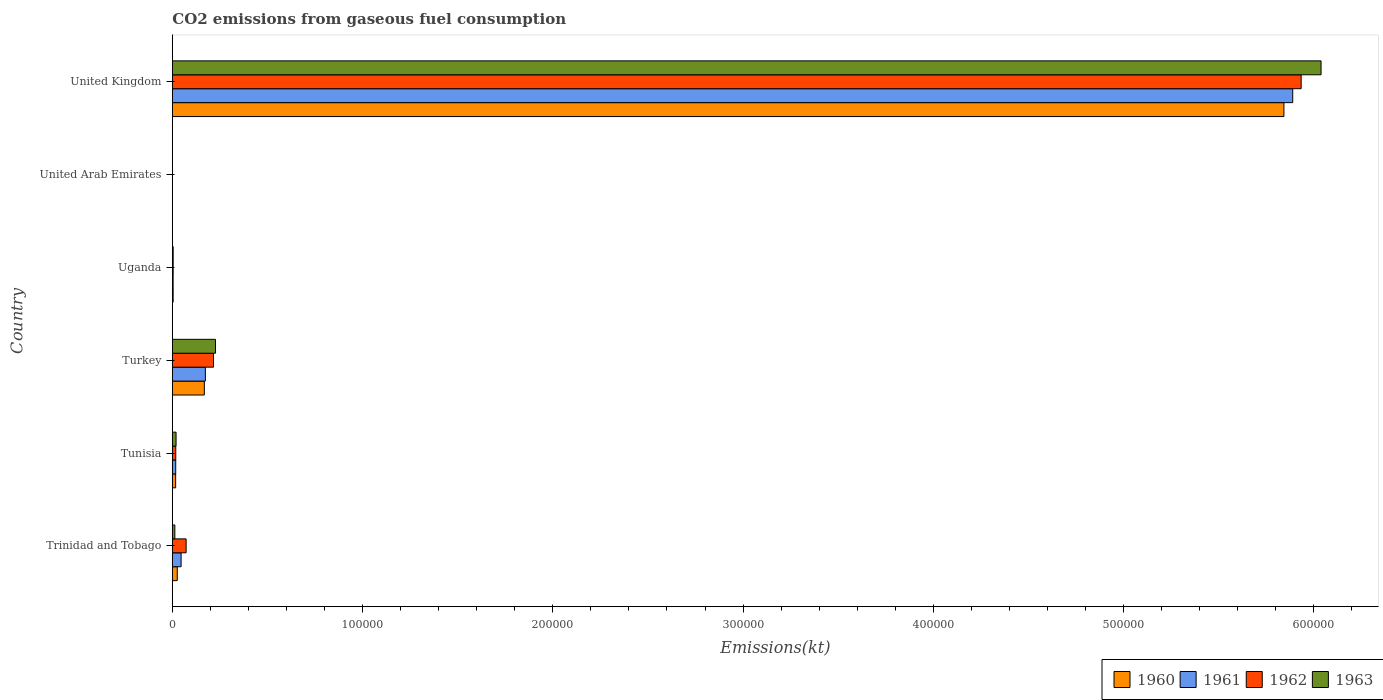Are the number of bars per tick equal to the number of legend labels?
Your answer should be compact. Yes. In how many cases, is the number of bars for a given country not equal to the number of legend labels?
Offer a very short reply. 0. What is the amount of CO2 emitted in 1963 in Tunisia?
Offer a very short reply. 1947.18. Across all countries, what is the maximum amount of CO2 emitted in 1960?
Your response must be concise. 5.84e+05. Across all countries, what is the minimum amount of CO2 emitted in 1961?
Make the answer very short. 11. In which country was the amount of CO2 emitted in 1962 minimum?
Keep it short and to the point. United Arab Emirates. What is the total amount of CO2 emitted in 1963 in the graph?
Give a very brief answer. 6.30e+05. What is the difference between the amount of CO2 emitted in 1960 in Tunisia and that in United Kingdom?
Your answer should be compact. -5.83e+05. What is the difference between the amount of CO2 emitted in 1961 in Trinidad and Tobago and the amount of CO2 emitted in 1960 in United Arab Emirates?
Your answer should be compact. 4591.08. What is the average amount of CO2 emitted in 1961 per country?
Offer a terse response. 1.02e+05. What is the difference between the amount of CO2 emitted in 1962 and amount of CO2 emitted in 1960 in Uganda?
Offer a terse response. 7.33. In how many countries, is the amount of CO2 emitted in 1963 greater than 160000 kt?
Your answer should be very brief. 1. What is the ratio of the amount of CO2 emitted in 1963 in Tunisia to that in Turkey?
Your answer should be very brief. 0.09. What is the difference between the highest and the second highest amount of CO2 emitted in 1960?
Your answer should be very brief. 5.67e+05. What is the difference between the highest and the lowest amount of CO2 emitted in 1962?
Keep it short and to the point. 5.93e+05. In how many countries, is the amount of CO2 emitted in 1960 greater than the average amount of CO2 emitted in 1960 taken over all countries?
Your answer should be very brief. 1. Is the sum of the amount of CO2 emitted in 1963 in Trinidad and Tobago and Tunisia greater than the maximum amount of CO2 emitted in 1960 across all countries?
Offer a very short reply. No. What does the 1st bar from the bottom in Trinidad and Tobago represents?
Offer a very short reply. 1960. Is it the case that in every country, the sum of the amount of CO2 emitted in 1961 and amount of CO2 emitted in 1960 is greater than the amount of CO2 emitted in 1963?
Keep it short and to the point. No. How many countries are there in the graph?
Make the answer very short. 6. What is the difference between two consecutive major ticks on the X-axis?
Your answer should be compact. 1.00e+05. Are the values on the major ticks of X-axis written in scientific E-notation?
Provide a short and direct response. No. Does the graph contain any zero values?
Offer a terse response. No. Where does the legend appear in the graph?
Your answer should be compact. Bottom right. What is the title of the graph?
Give a very brief answer. CO2 emissions from gaseous fuel consumption. What is the label or title of the X-axis?
Your answer should be very brief. Emissions(kt). What is the Emissions(kt) in 1960 in Trinidad and Tobago?
Your response must be concise. 2581.57. What is the Emissions(kt) in 1961 in Trinidad and Tobago?
Make the answer very short. 4602.09. What is the Emissions(kt) in 1962 in Trinidad and Tobago?
Your response must be concise. 7238.66. What is the Emissions(kt) of 1963 in Trinidad and Tobago?
Your answer should be very brief. 1309.12. What is the Emissions(kt) in 1960 in Tunisia?
Keep it short and to the point. 1727.16. What is the Emissions(kt) in 1961 in Tunisia?
Offer a very short reply. 1767.49. What is the Emissions(kt) of 1962 in Tunisia?
Your answer should be very brief. 1796.83. What is the Emissions(kt) of 1963 in Tunisia?
Provide a succinct answer. 1947.18. What is the Emissions(kt) in 1960 in Turkey?
Ensure brevity in your answer.  1.68e+04. What is the Emissions(kt) of 1961 in Turkey?
Ensure brevity in your answer.  1.74e+04. What is the Emissions(kt) in 1962 in Turkey?
Keep it short and to the point. 2.16e+04. What is the Emissions(kt) in 1963 in Turkey?
Provide a short and direct response. 2.27e+04. What is the Emissions(kt) in 1960 in Uganda?
Make the answer very short. 421.7. What is the Emissions(kt) in 1961 in Uganda?
Make the answer very short. 407.04. What is the Emissions(kt) in 1962 in Uganda?
Give a very brief answer. 429.04. What is the Emissions(kt) in 1963 in Uganda?
Give a very brief answer. 432.71. What is the Emissions(kt) in 1960 in United Arab Emirates?
Keep it short and to the point. 11. What is the Emissions(kt) of 1961 in United Arab Emirates?
Keep it short and to the point. 11. What is the Emissions(kt) in 1962 in United Arab Emirates?
Ensure brevity in your answer.  18.34. What is the Emissions(kt) of 1963 in United Arab Emirates?
Your response must be concise. 22. What is the Emissions(kt) of 1960 in United Kingdom?
Offer a very short reply. 5.84e+05. What is the Emissions(kt) of 1961 in United Kingdom?
Give a very brief answer. 5.89e+05. What is the Emissions(kt) of 1962 in United Kingdom?
Give a very brief answer. 5.93e+05. What is the Emissions(kt) of 1963 in United Kingdom?
Give a very brief answer. 6.04e+05. Across all countries, what is the maximum Emissions(kt) of 1960?
Offer a terse response. 5.84e+05. Across all countries, what is the maximum Emissions(kt) of 1961?
Provide a succinct answer. 5.89e+05. Across all countries, what is the maximum Emissions(kt) of 1962?
Give a very brief answer. 5.93e+05. Across all countries, what is the maximum Emissions(kt) of 1963?
Offer a very short reply. 6.04e+05. Across all countries, what is the minimum Emissions(kt) of 1960?
Your response must be concise. 11. Across all countries, what is the minimum Emissions(kt) in 1961?
Offer a terse response. 11. Across all countries, what is the minimum Emissions(kt) in 1962?
Keep it short and to the point. 18.34. Across all countries, what is the minimum Emissions(kt) in 1963?
Provide a short and direct response. 22. What is the total Emissions(kt) in 1960 in the graph?
Your answer should be very brief. 6.06e+05. What is the total Emissions(kt) of 1961 in the graph?
Keep it short and to the point. 6.13e+05. What is the total Emissions(kt) of 1962 in the graph?
Your response must be concise. 6.24e+05. What is the total Emissions(kt) in 1963 in the graph?
Make the answer very short. 6.30e+05. What is the difference between the Emissions(kt) in 1960 in Trinidad and Tobago and that in Tunisia?
Your answer should be compact. 854.41. What is the difference between the Emissions(kt) in 1961 in Trinidad and Tobago and that in Tunisia?
Offer a very short reply. 2834.59. What is the difference between the Emissions(kt) of 1962 in Trinidad and Tobago and that in Tunisia?
Give a very brief answer. 5441.83. What is the difference between the Emissions(kt) of 1963 in Trinidad and Tobago and that in Tunisia?
Your answer should be very brief. -638.06. What is the difference between the Emissions(kt) in 1960 in Trinidad and Tobago and that in Turkey?
Provide a succinct answer. -1.42e+04. What is the difference between the Emissions(kt) in 1961 in Trinidad and Tobago and that in Turkey?
Ensure brevity in your answer.  -1.28e+04. What is the difference between the Emissions(kt) of 1962 in Trinidad and Tobago and that in Turkey?
Your answer should be compact. -1.44e+04. What is the difference between the Emissions(kt) in 1963 in Trinidad and Tobago and that in Turkey?
Keep it short and to the point. -2.14e+04. What is the difference between the Emissions(kt) of 1960 in Trinidad and Tobago and that in Uganda?
Ensure brevity in your answer.  2159.86. What is the difference between the Emissions(kt) in 1961 in Trinidad and Tobago and that in Uganda?
Your answer should be very brief. 4195.05. What is the difference between the Emissions(kt) in 1962 in Trinidad and Tobago and that in Uganda?
Your answer should be very brief. 6809.62. What is the difference between the Emissions(kt) in 1963 in Trinidad and Tobago and that in Uganda?
Your answer should be compact. 876.41. What is the difference between the Emissions(kt) of 1960 in Trinidad and Tobago and that in United Arab Emirates?
Ensure brevity in your answer.  2570.57. What is the difference between the Emissions(kt) of 1961 in Trinidad and Tobago and that in United Arab Emirates?
Provide a succinct answer. 4591.08. What is the difference between the Emissions(kt) of 1962 in Trinidad and Tobago and that in United Arab Emirates?
Your answer should be compact. 7220.32. What is the difference between the Emissions(kt) of 1963 in Trinidad and Tobago and that in United Arab Emirates?
Offer a very short reply. 1287.12. What is the difference between the Emissions(kt) in 1960 in Trinidad and Tobago and that in United Kingdom?
Offer a very short reply. -5.82e+05. What is the difference between the Emissions(kt) in 1961 in Trinidad and Tobago and that in United Kingdom?
Your answer should be compact. -5.84e+05. What is the difference between the Emissions(kt) in 1962 in Trinidad and Tobago and that in United Kingdom?
Keep it short and to the point. -5.86e+05. What is the difference between the Emissions(kt) in 1963 in Trinidad and Tobago and that in United Kingdom?
Offer a very short reply. -6.03e+05. What is the difference between the Emissions(kt) of 1960 in Tunisia and that in Turkey?
Make the answer very short. -1.51e+04. What is the difference between the Emissions(kt) in 1961 in Tunisia and that in Turkey?
Your response must be concise. -1.56e+04. What is the difference between the Emissions(kt) in 1962 in Tunisia and that in Turkey?
Offer a terse response. -1.98e+04. What is the difference between the Emissions(kt) in 1963 in Tunisia and that in Turkey?
Offer a very short reply. -2.07e+04. What is the difference between the Emissions(kt) in 1960 in Tunisia and that in Uganda?
Your answer should be compact. 1305.45. What is the difference between the Emissions(kt) of 1961 in Tunisia and that in Uganda?
Provide a short and direct response. 1360.46. What is the difference between the Emissions(kt) of 1962 in Tunisia and that in Uganda?
Make the answer very short. 1367.79. What is the difference between the Emissions(kt) in 1963 in Tunisia and that in Uganda?
Provide a short and direct response. 1514.47. What is the difference between the Emissions(kt) in 1960 in Tunisia and that in United Arab Emirates?
Offer a terse response. 1716.16. What is the difference between the Emissions(kt) of 1961 in Tunisia and that in United Arab Emirates?
Offer a very short reply. 1756.49. What is the difference between the Emissions(kt) in 1962 in Tunisia and that in United Arab Emirates?
Your answer should be very brief. 1778.49. What is the difference between the Emissions(kt) in 1963 in Tunisia and that in United Arab Emirates?
Provide a succinct answer. 1925.17. What is the difference between the Emissions(kt) of 1960 in Tunisia and that in United Kingdom?
Your answer should be compact. -5.83e+05. What is the difference between the Emissions(kt) of 1961 in Tunisia and that in United Kingdom?
Make the answer very short. -5.87e+05. What is the difference between the Emissions(kt) of 1962 in Tunisia and that in United Kingdom?
Make the answer very short. -5.92e+05. What is the difference between the Emissions(kt) of 1963 in Tunisia and that in United Kingdom?
Offer a very short reply. -6.02e+05. What is the difference between the Emissions(kt) in 1960 in Turkey and that in Uganda?
Your response must be concise. 1.64e+04. What is the difference between the Emissions(kt) of 1961 in Turkey and that in Uganda?
Your answer should be very brief. 1.70e+04. What is the difference between the Emissions(kt) in 1962 in Turkey and that in Uganda?
Provide a short and direct response. 2.12e+04. What is the difference between the Emissions(kt) of 1963 in Turkey and that in Uganda?
Your answer should be compact. 2.22e+04. What is the difference between the Emissions(kt) in 1960 in Turkey and that in United Arab Emirates?
Your answer should be very brief. 1.68e+04. What is the difference between the Emissions(kt) of 1961 in Turkey and that in United Arab Emirates?
Offer a very short reply. 1.74e+04. What is the difference between the Emissions(kt) of 1962 in Turkey and that in United Arab Emirates?
Your answer should be compact. 2.16e+04. What is the difference between the Emissions(kt) of 1963 in Turkey and that in United Arab Emirates?
Your answer should be compact. 2.26e+04. What is the difference between the Emissions(kt) of 1960 in Turkey and that in United Kingdom?
Your answer should be very brief. -5.67e+05. What is the difference between the Emissions(kt) in 1961 in Turkey and that in United Kingdom?
Keep it short and to the point. -5.72e+05. What is the difference between the Emissions(kt) in 1962 in Turkey and that in United Kingdom?
Give a very brief answer. -5.72e+05. What is the difference between the Emissions(kt) in 1963 in Turkey and that in United Kingdom?
Your answer should be very brief. -5.81e+05. What is the difference between the Emissions(kt) in 1960 in Uganda and that in United Arab Emirates?
Provide a short and direct response. 410.7. What is the difference between the Emissions(kt) in 1961 in Uganda and that in United Arab Emirates?
Ensure brevity in your answer.  396.04. What is the difference between the Emissions(kt) in 1962 in Uganda and that in United Arab Emirates?
Ensure brevity in your answer.  410.7. What is the difference between the Emissions(kt) of 1963 in Uganda and that in United Arab Emirates?
Your answer should be very brief. 410.7. What is the difference between the Emissions(kt) of 1960 in Uganda and that in United Kingdom?
Ensure brevity in your answer.  -5.84e+05. What is the difference between the Emissions(kt) in 1961 in Uganda and that in United Kingdom?
Ensure brevity in your answer.  -5.89e+05. What is the difference between the Emissions(kt) of 1962 in Uganda and that in United Kingdom?
Your answer should be compact. -5.93e+05. What is the difference between the Emissions(kt) in 1963 in Uganda and that in United Kingdom?
Give a very brief answer. -6.03e+05. What is the difference between the Emissions(kt) of 1960 in United Arab Emirates and that in United Kingdom?
Provide a short and direct response. -5.84e+05. What is the difference between the Emissions(kt) in 1961 in United Arab Emirates and that in United Kingdom?
Provide a short and direct response. -5.89e+05. What is the difference between the Emissions(kt) in 1962 in United Arab Emirates and that in United Kingdom?
Make the answer very short. -5.93e+05. What is the difference between the Emissions(kt) of 1963 in United Arab Emirates and that in United Kingdom?
Offer a terse response. -6.04e+05. What is the difference between the Emissions(kt) of 1960 in Trinidad and Tobago and the Emissions(kt) of 1961 in Tunisia?
Offer a terse response. 814.07. What is the difference between the Emissions(kt) of 1960 in Trinidad and Tobago and the Emissions(kt) of 1962 in Tunisia?
Your answer should be compact. 784.74. What is the difference between the Emissions(kt) in 1960 in Trinidad and Tobago and the Emissions(kt) in 1963 in Tunisia?
Give a very brief answer. 634.39. What is the difference between the Emissions(kt) in 1961 in Trinidad and Tobago and the Emissions(kt) in 1962 in Tunisia?
Your answer should be very brief. 2805.26. What is the difference between the Emissions(kt) in 1961 in Trinidad and Tobago and the Emissions(kt) in 1963 in Tunisia?
Your answer should be compact. 2654.91. What is the difference between the Emissions(kt) in 1962 in Trinidad and Tobago and the Emissions(kt) in 1963 in Tunisia?
Your answer should be compact. 5291.48. What is the difference between the Emissions(kt) in 1960 in Trinidad and Tobago and the Emissions(kt) in 1961 in Turkey?
Keep it short and to the point. -1.48e+04. What is the difference between the Emissions(kt) of 1960 in Trinidad and Tobago and the Emissions(kt) of 1962 in Turkey?
Your response must be concise. -1.91e+04. What is the difference between the Emissions(kt) in 1960 in Trinidad and Tobago and the Emissions(kt) in 1963 in Turkey?
Your response must be concise. -2.01e+04. What is the difference between the Emissions(kt) of 1961 in Trinidad and Tobago and the Emissions(kt) of 1962 in Turkey?
Ensure brevity in your answer.  -1.70e+04. What is the difference between the Emissions(kt) of 1961 in Trinidad and Tobago and the Emissions(kt) of 1963 in Turkey?
Make the answer very short. -1.81e+04. What is the difference between the Emissions(kt) of 1962 in Trinidad and Tobago and the Emissions(kt) of 1963 in Turkey?
Provide a succinct answer. -1.54e+04. What is the difference between the Emissions(kt) of 1960 in Trinidad and Tobago and the Emissions(kt) of 1961 in Uganda?
Ensure brevity in your answer.  2174.53. What is the difference between the Emissions(kt) in 1960 in Trinidad and Tobago and the Emissions(kt) in 1962 in Uganda?
Ensure brevity in your answer.  2152.53. What is the difference between the Emissions(kt) in 1960 in Trinidad and Tobago and the Emissions(kt) in 1963 in Uganda?
Your response must be concise. 2148.86. What is the difference between the Emissions(kt) in 1961 in Trinidad and Tobago and the Emissions(kt) in 1962 in Uganda?
Your response must be concise. 4173.05. What is the difference between the Emissions(kt) of 1961 in Trinidad and Tobago and the Emissions(kt) of 1963 in Uganda?
Ensure brevity in your answer.  4169.38. What is the difference between the Emissions(kt) in 1962 in Trinidad and Tobago and the Emissions(kt) in 1963 in Uganda?
Provide a succinct answer. 6805.95. What is the difference between the Emissions(kt) in 1960 in Trinidad and Tobago and the Emissions(kt) in 1961 in United Arab Emirates?
Offer a terse response. 2570.57. What is the difference between the Emissions(kt) of 1960 in Trinidad and Tobago and the Emissions(kt) of 1962 in United Arab Emirates?
Make the answer very short. 2563.23. What is the difference between the Emissions(kt) in 1960 in Trinidad and Tobago and the Emissions(kt) in 1963 in United Arab Emirates?
Your answer should be very brief. 2559.57. What is the difference between the Emissions(kt) of 1961 in Trinidad and Tobago and the Emissions(kt) of 1962 in United Arab Emirates?
Give a very brief answer. 4583.75. What is the difference between the Emissions(kt) in 1961 in Trinidad and Tobago and the Emissions(kt) in 1963 in United Arab Emirates?
Provide a succinct answer. 4580.08. What is the difference between the Emissions(kt) of 1962 in Trinidad and Tobago and the Emissions(kt) of 1963 in United Arab Emirates?
Give a very brief answer. 7216.66. What is the difference between the Emissions(kt) of 1960 in Trinidad and Tobago and the Emissions(kt) of 1961 in United Kingdom?
Your answer should be compact. -5.86e+05. What is the difference between the Emissions(kt) of 1960 in Trinidad and Tobago and the Emissions(kt) of 1962 in United Kingdom?
Provide a short and direct response. -5.91e+05. What is the difference between the Emissions(kt) in 1960 in Trinidad and Tobago and the Emissions(kt) in 1963 in United Kingdom?
Your answer should be compact. -6.01e+05. What is the difference between the Emissions(kt) in 1961 in Trinidad and Tobago and the Emissions(kt) in 1962 in United Kingdom?
Your answer should be compact. -5.89e+05. What is the difference between the Emissions(kt) of 1961 in Trinidad and Tobago and the Emissions(kt) of 1963 in United Kingdom?
Your answer should be compact. -5.99e+05. What is the difference between the Emissions(kt) in 1962 in Trinidad and Tobago and the Emissions(kt) in 1963 in United Kingdom?
Your response must be concise. -5.97e+05. What is the difference between the Emissions(kt) of 1960 in Tunisia and the Emissions(kt) of 1961 in Turkey?
Provide a short and direct response. -1.56e+04. What is the difference between the Emissions(kt) in 1960 in Tunisia and the Emissions(kt) in 1962 in Turkey?
Provide a short and direct response. -1.99e+04. What is the difference between the Emissions(kt) in 1960 in Tunisia and the Emissions(kt) in 1963 in Turkey?
Offer a very short reply. -2.09e+04. What is the difference between the Emissions(kt) in 1961 in Tunisia and the Emissions(kt) in 1962 in Turkey?
Your answer should be compact. -1.99e+04. What is the difference between the Emissions(kt) in 1961 in Tunisia and the Emissions(kt) in 1963 in Turkey?
Ensure brevity in your answer.  -2.09e+04. What is the difference between the Emissions(kt) in 1962 in Tunisia and the Emissions(kt) in 1963 in Turkey?
Your answer should be compact. -2.09e+04. What is the difference between the Emissions(kt) in 1960 in Tunisia and the Emissions(kt) in 1961 in Uganda?
Your answer should be very brief. 1320.12. What is the difference between the Emissions(kt) of 1960 in Tunisia and the Emissions(kt) of 1962 in Uganda?
Offer a very short reply. 1298.12. What is the difference between the Emissions(kt) in 1960 in Tunisia and the Emissions(kt) in 1963 in Uganda?
Offer a terse response. 1294.45. What is the difference between the Emissions(kt) in 1961 in Tunisia and the Emissions(kt) in 1962 in Uganda?
Your answer should be very brief. 1338.45. What is the difference between the Emissions(kt) of 1961 in Tunisia and the Emissions(kt) of 1963 in Uganda?
Provide a short and direct response. 1334.79. What is the difference between the Emissions(kt) in 1962 in Tunisia and the Emissions(kt) in 1963 in Uganda?
Make the answer very short. 1364.12. What is the difference between the Emissions(kt) in 1960 in Tunisia and the Emissions(kt) in 1961 in United Arab Emirates?
Provide a short and direct response. 1716.16. What is the difference between the Emissions(kt) in 1960 in Tunisia and the Emissions(kt) in 1962 in United Arab Emirates?
Offer a very short reply. 1708.82. What is the difference between the Emissions(kt) in 1960 in Tunisia and the Emissions(kt) in 1963 in United Arab Emirates?
Give a very brief answer. 1705.15. What is the difference between the Emissions(kt) of 1961 in Tunisia and the Emissions(kt) of 1962 in United Arab Emirates?
Give a very brief answer. 1749.16. What is the difference between the Emissions(kt) in 1961 in Tunisia and the Emissions(kt) in 1963 in United Arab Emirates?
Your answer should be compact. 1745.49. What is the difference between the Emissions(kt) in 1962 in Tunisia and the Emissions(kt) in 1963 in United Arab Emirates?
Ensure brevity in your answer.  1774.83. What is the difference between the Emissions(kt) of 1960 in Tunisia and the Emissions(kt) of 1961 in United Kingdom?
Keep it short and to the point. -5.87e+05. What is the difference between the Emissions(kt) of 1960 in Tunisia and the Emissions(kt) of 1962 in United Kingdom?
Give a very brief answer. -5.92e+05. What is the difference between the Emissions(kt) in 1960 in Tunisia and the Emissions(kt) in 1963 in United Kingdom?
Ensure brevity in your answer.  -6.02e+05. What is the difference between the Emissions(kt) in 1961 in Tunisia and the Emissions(kt) in 1962 in United Kingdom?
Offer a terse response. -5.92e+05. What is the difference between the Emissions(kt) of 1961 in Tunisia and the Emissions(kt) of 1963 in United Kingdom?
Your response must be concise. -6.02e+05. What is the difference between the Emissions(kt) of 1962 in Tunisia and the Emissions(kt) of 1963 in United Kingdom?
Give a very brief answer. -6.02e+05. What is the difference between the Emissions(kt) of 1960 in Turkey and the Emissions(kt) of 1961 in Uganda?
Your response must be concise. 1.64e+04. What is the difference between the Emissions(kt) in 1960 in Turkey and the Emissions(kt) in 1962 in Uganda?
Provide a short and direct response. 1.64e+04. What is the difference between the Emissions(kt) in 1960 in Turkey and the Emissions(kt) in 1963 in Uganda?
Offer a terse response. 1.64e+04. What is the difference between the Emissions(kt) of 1961 in Turkey and the Emissions(kt) of 1962 in Uganda?
Keep it short and to the point. 1.69e+04. What is the difference between the Emissions(kt) in 1961 in Turkey and the Emissions(kt) in 1963 in Uganda?
Provide a short and direct response. 1.69e+04. What is the difference between the Emissions(kt) of 1962 in Turkey and the Emissions(kt) of 1963 in Uganda?
Give a very brief answer. 2.12e+04. What is the difference between the Emissions(kt) of 1960 in Turkey and the Emissions(kt) of 1961 in United Arab Emirates?
Provide a short and direct response. 1.68e+04. What is the difference between the Emissions(kt) in 1960 in Turkey and the Emissions(kt) in 1962 in United Arab Emirates?
Keep it short and to the point. 1.68e+04. What is the difference between the Emissions(kt) of 1960 in Turkey and the Emissions(kt) of 1963 in United Arab Emirates?
Give a very brief answer. 1.68e+04. What is the difference between the Emissions(kt) in 1961 in Turkey and the Emissions(kt) in 1962 in United Arab Emirates?
Ensure brevity in your answer.  1.73e+04. What is the difference between the Emissions(kt) of 1961 in Turkey and the Emissions(kt) of 1963 in United Arab Emirates?
Your answer should be very brief. 1.73e+04. What is the difference between the Emissions(kt) of 1962 in Turkey and the Emissions(kt) of 1963 in United Arab Emirates?
Give a very brief answer. 2.16e+04. What is the difference between the Emissions(kt) of 1960 in Turkey and the Emissions(kt) of 1961 in United Kingdom?
Your answer should be very brief. -5.72e+05. What is the difference between the Emissions(kt) of 1960 in Turkey and the Emissions(kt) of 1962 in United Kingdom?
Offer a very short reply. -5.77e+05. What is the difference between the Emissions(kt) in 1960 in Turkey and the Emissions(kt) in 1963 in United Kingdom?
Provide a succinct answer. -5.87e+05. What is the difference between the Emissions(kt) of 1961 in Turkey and the Emissions(kt) of 1962 in United Kingdom?
Offer a very short reply. -5.76e+05. What is the difference between the Emissions(kt) of 1961 in Turkey and the Emissions(kt) of 1963 in United Kingdom?
Provide a short and direct response. -5.86e+05. What is the difference between the Emissions(kt) in 1962 in Turkey and the Emissions(kt) in 1963 in United Kingdom?
Your response must be concise. -5.82e+05. What is the difference between the Emissions(kt) of 1960 in Uganda and the Emissions(kt) of 1961 in United Arab Emirates?
Give a very brief answer. 410.7. What is the difference between the Emissions(kt) in 1960 in Uganda and the Emissions(kt) in 1962 in United Arab Emirates?
Provide a short and direct response. 403.37. What is the difference between the Emissions(kt) of 1960 in Uganda and the Emissions(kt) of 1963 in United Arab Emirates?
Make the answer very short. 399.7. What is the difference between the Emissions(kt) of 1961 in Uganda and the Emissions(kt) of 1962 in United Arab Emirates?
Your response must be concise. 388.7. What is the difference between the Emissions(kt) of 1961 in Uganda and the Emissions(kt) of 1963 in United Arab Emirates?
Provide a succinct answer. 385.04. What is the difference between the Emissions(kt) of 1962 in Uganda and the Emissions(kt) of 1963 in United Arab Emirates?
Offer a terse response. 407.04. What is the difference between the Emissions(kt) in 1960 in Uganda and the Emissions(kt) in 1961 in United Kingdom?
Ensure brevity in your answer.  -5.89e+05. What is the difference between the Emissions(kt) of 1960 in Uganda and the Emissions(kt) of 1962 in United Kingdom?
Offer a very short reply. -5.93e+05. What is the difference between the Emissions(kt) in 1960 in Uganda and the Emissions(kt) in 1963 in United Kingdom?
Make the answer very short. -6.03e+05. What is the difference between the Emissions(kt) of 1961 in Uganda and the Emissions(kt) of 1962 in United Kingdom?
Offer a terse response. -5.93e+05. What is the difference between the Emissions(kt) in 1961 in Uganda and the Emissions(kt) in 1963 in United Kingdom?
Offer a very short reply. -6.03e+05. What is the difference between the Emissions(kt) in 1962 in Uganda and the Emissions(kt) in 1963 in United Kingdom?
Ensure brevity in your answer.  -6.03e+05. What is the difference between the Emissions(kt) in 1960 in United Arab Emirates and the Emissions(kt) in 1961 in United Kingdom?
Your response must be concise. -5.89e+05. What is the difference between the Emissions(kt) of 1960 in United Arab Emirates and the Emissions(kt) of 1962 in United Kingdom?
Make the answer very short. -5.93e+05. What is the difference between the Emissions(kt) of 1960 in United Arab Emirates and the Emissions(kt) of 1963 in United Kingdom?
Your response must be concise. -6.04e+05. What is the difference between the Emissions(kt) of 1961 in United Arab Emirates and the Emissions(kt) of 1962 in United Kingdom?
Keep it short and to the point. -5.93e+05. What is the difference between the Emissions(kt) of 1961 in United Arab Emirates and the Emissions(kt) of 1963 in United Kingdom?
Your response must be concise. -6.04e+05. What is the difference between the Emissions(kt) in 1962 in United Arab Emirates and the Emissions(kt) in 1963 in United Kingdom?
Your response must be concise. -6.04e+05. What is the average Emissions(kt) in 1960 per country?
Your answer should be very brief. 1.01e+05. What is the average Emissions(kt) in 1961 per country?
Keep it short and to the point. 1.02e+05. What is the average Emissions(kt) of 1962 per country?
Offer a very short reply. 1.04e+05. What is the average Emissions(kt) in 1963 per country?
Provide a short and direct response. 1.05e+05. What is the difference between the Emissions(kt) in 1960 and Emissions(kt) in 1961 in Trinidad and Tobago?
Make the answer very short. -2020.52. What is the difference between the Emissions(kt) in 1960 and Emissions(kt) in 1962 in Trinidad and Tobago?
Ensure brevity in your answer.  -4657.09. What is the difference between the Emissions(kt) in 1960 and Emissions(kt) in 1963 in Trinidad and Tobago?
Keep it short and to the point. 1272.45. What is the difference between the Emissions(kt) in 1961 and Emissions(kt) in 1962 in Trinidad and Tobago?
Ensure brevity in your answer.  -2636.57. What is the difference between the Emissions(kt) of 1961 and Emissions(kt) of 1963 in Trinidad and Tobago?
Provide a succinct answer. 3292.97. What is the difference between the Emissions(kt) in 1962 and Emissions(kt) in 1963 in Trinidad and Tobago?
Provide a short and direct response. 5929.54. What is the difference between the Emissions(kt) in 1960 and Emissions(kt) in 1961 in Tunisia?
Your answer should be very brief. -40.34. What is the difference between the Emissions(kt) in 1960 and Emissions(kt) in 1962 in Tunisia?
Your answer should be very brief. -69.67. What is the difference between the Emissions(kt) of 1960 and Emissions(kt) of 1963 in Tunisia?
Your answer should be compact. -220.02. What is the difference between the Emissions(kt) in 1961 and Emissions(kt) in 1962 in Tunisia?
Your answer should be very brief. -29.34. What is the difference between the Emissions(kt) of 1961 and Emissions(kt) of 1963 in Tunisia?
Offer a very short reply. -179.68. What is the difference between the Emissions(kt) in 1962 and Emissions(kt) in 1963 in Tunisia?
Your answer should be very brief. -150.35. What is the difference between the Emissions(kt) in 1960 and Emissions(kt) in 1961 in Turkey?
Keep it short and to the point. -542.72. What is the difference between the Emissions(kt) of 1960 and Emissions(kt) of 1962 in Turkey?
Keep it short and to the point. -4811.1. What is the difference between the Emissions(kt) of 1960 and Emissions(kt) of 1963 in Turkey?
Offer a very short reply. -5848.86. What is the difference between the Emissions(kt) in 1961 and Emissions(kt) in 1962 in Turkey?
Offer a terse response. -4268.39. What is the difference between the Emissions(kt) of 1961 and Emissions(kt) of 1963 in Turkey?
Give a very brief answer. -5306.15. What is the difference between the Emissions(kt) of 1962 and Emissions(kt) of 1963 in Turkey?
Keep it short and to the point. -1037.76. What is the difference between the Emissions(kt) of 1960 and Emissions(kt) of 1961 in Uganda?
Make the answer very short. 14.67. What is the difference between the Emissions(kt) in 1960 and Emissions(kt) in 1962 in Uganda?
Provide a succinct answer. -7.33. What is the difference between the Emissions(kt) in 1960 and Emissions(kt) in 1963 in Uganda?
Offer a terse response. -11. What is the difference between the Emissions(kt) of 1961 and Emissions(kt) of 1962 in Uganda?
Offer a terse response. -22. What is the difference between the Emissions(kt) of 1961 and Emissions(kt) of 1963 in Uganda?
Your answer should be very brief. -25.67. What is the difference between the Emissions(kt) in 1962 and Emissions(kt) in 1963 in Uganda?
Make the answer very short. -3.67. What is the difference between the Emissions(kt) of 1960 and Emissions(kt) of 1962 in United Arab Emirates?
Keep it short and to the point. -7.33. What is the difference between the Emissions(kt) of 1960 and Emissions(kt) of 1963 in United Arab Emirates?
Ensure brevity in your answer.  -11. What is the difference between the Emissions(kt) in 1961 and Emissions(kt) in 1962 in United Arab Emirates?
Make the answer very short. -7.33. What is the difference between the Emissions(kt) in 1961 and Emissions(kt) in 1963 in United Arab Emirates?
Ensure brevity in your answer.  -11. What is the difference between the Emissions(kt) of 1962 and Emissions(kt) of 1963 in United Arab Emirates?
Ensure brevity in your answer.  -3.67. What is the difference between the Emissions(kt) in 1960 and Emissions(kt) in 1961 in United Kingdom?
Ensure brevity in your answer.  -4638.76. What is the difference between the Emissions(kt) of 1960 and Emissions(kt) of 1962 in United Kingdom?
Keep it short and to the point. -9061.16. What is the difference between the Emissions(kt) in 1960 and Emissions(kt) in 1963 in United Kingdom?
Your response must be concise. -1.95e+04. What is the difference between the Emissions(kt) in 1961 and Emissions(kt) in 1962 in United Kingdom?
Offer a very short reply. -4422.4. What is the difference between the Emissions(kt) of 1961 and Emissions(kt) of 1963 in United Kingdom?
Make the answer very short. -1.49e+04. What is the difference between the Emissions(kt) in 1962 and Emissions(kt) in 1963 in United Kingdom?
Give a very brief answer. -1.05e+04. What is the ratio of the Emissions(kt) of 1960 in Trinidad and Tobago to that in Tunisia?
Your response must be concise. 1.49. What is the ratio of the Emissions(kt) of 1961 in Trinidad and Tobago to that in Tunisia?
Your answer should be compact. 2.6. What is the ratio of the Emissions(kt) in 1962 in Trinidad and Tobago to that in Tunisia?
Your answer should be compact. 4.03. What is the ratio of the Emissions(kt) in 1963 in Trinidad and Tobago to that in Tunisia?
Make the answer very short. 0.67. What is the ratio of the Emissions(kt) of 1960 in Trinidad and Tobago to that in Turkey?
Your response must be concise. 0.15. What is the ratio of the Emissions(kt) in 1961 in Trinidad and Tobago to that in Turkey?
Provide a short and direct response. 0.27. What is the ratio of the Emissions(kt) in 1962 in Trinidad and Tobago to that in Turkey?
Keep it short and to the point. 0.33. What is the ratio of the Emissions(kt) in 1963 in Trinidad and Tobago to that in Turkey?
Make the answer very short. 0.06. What is the ratio of the Emissions(kt) in 1960 in Trinidad and Tobago to that in Uganda?
Give a very brief answer. 6.12. What is the ratio of the Emissions(kt) in 1961 in Trinidad and Tobago to that in Uganda?
Your answer should be very brief. 11.31. What is the ratio of the Emissions(kt) of 1962 in Trinidad and Tobago to that in Uganda?
Provide a succinct answer. 16.87. What is the ratio of the Emissions(kt) in 1963 in Trinidad and Tobago to that in Uganda?
Your answer should be compact. 3.03. What is the ratio of the Emissions(kt) in 1960 in Trinidad and Tobago to that in United Arab Emirates?
Make the answer very short. 234.67. What is the ratio of the Emissions(kt) of 1961 in Trinidad and Tobago to that in United Arab Emirates?
Your response must be concise. 418.33. What is the ratio of the Emissions(kt) of 1962 in Trinidad and Tobago to that in United Arab Emirates?
Provide a succinct answer. 394.8. What is the ratio of the Emissions(kt) in 1963 in Trinidad and Tobago to that in United Arab Emirates?
Keep it short and to the point. 59.5. What is the ratio of the Emissions(kt) in 1960 in Trinidad and Tobago to that in United Kingdom?
Keep it short and to the point. 0. What is the ratio of the Emissions(kt) in 1961 in Trinidad and Tobago to that in United Kingdom?
Ensure brevity in your answer.  0.01. What is the ratio of the Emissions(kt) of 1962 in Trinidad and Tobago to that in United Kingdom?
Give a very brief answer. 0.01. What is the ratio of the Emissions(kt) in 1963 in Trinidad and Tobago to that in United Kingdom?
Give a very brief answer. 0. What is the ratio of the Emissions(kt) in 1960 in Tunisia to that in Turkey?
Your answer should be compact. 0.1. What is the ratio of the Emissions(kt) in 1961 in Tunisia to that in Turkey?
Make the answer very short. 0.1. What is the ratio of the Emissions(kt) of 1962 in Tunisia to that in Turkey?
Offer a very short reply. 0.08. What is the ratio of the Emissions(kt) in 1963 in Tunisia to that in Turkey?
Keep it short and to the point. 0.09. What is the ratio of the Emissions(kt) in 1960 in Tunisia to that in Uganda?
Your answer should be very brief. 4.1. What is the ratio of the Emissions(kt) of 1961 in Tunisia to that in Uganda?
Offer a terse response. 4.34. What is the ratio of the Emissions(kt) of 1962 in Tunisia to that in Uganda?
Your answer should be compact. 4.19. What is the ratio of the Emissions(kt) in 1960 in Tunisia to that in United Arab Emirates?
Ensure brevity in your answer.  157. What is the ratio of the Emissions(kt) of 1961 in Tunisia to that in United Arab Emirates?
Ensure brevity in your answer.  160.67. What is the ratio of the Emissions(kt) in 1963 in Tunisia to that in United Arab Emirates?
Ensure brevity in your answer.  88.5. What is the ratio of the Emissions(kt) in 1960 in Tunisia to that in United Kingdom?
Give a very brief answer. 0. What is the ratio of the Emissions(kt) of 1961 in Tunisia to that in United Kingdom?
Your answer should be very brief. 0. What is the ratio of the Emissions(kt) of 1962 in Tunisia to that in United Kingdom?
Your answer should be compact. 0. What is the ratio of the Emissions(kt) of 1963 in Tunisia to that in United Kingdom?
Your answer should be very brief. 0. What is the ratio of the Emissions(kt) of 1960 in Turkey to that in Uganda?
Your answer should be compact. 39.89. What is the ratio of the Emissions(kt) of 1961 in Turkey to that in Uganda?
Provide a short and direct response. 42.66. What is the ratio of the Emissions(kt) of 1962 in Turkey to that in Uganda?
Your response must be concise. 50.42. What is the ratio of the Emissions(kt) of 1963 in Turkey to that in Uganda?
Your answer should be very brief. 52.39. What is the ratio of the Emissions(kt) in 1960 in Turkey to that in United Arab Emirates?
Ensure brevity in your answer.  1529. What is the ratio of the Emissions(kt) of 1961 in Turkey to that in United Arab Emirates?
Make the answer very short. 1578.33. What is the ratio of the Emissions(kt) in 1962 in Turkey to that in United Arab Emirates?
Ensure brevity in your answer.  1179.8. What is the ratio of the Emissions(kt) in 1963 in Turkey to that in United Arab Emirates?
Your answer should be very brief. 1030.33. What is the ratio of the Emissions(kt) of 1960 in Turkey to that in United Kingdom?
Provide a short and direct response. 0.03. What is the ratio of the Emissions(kt) of 1961 in Turkey to that in United Kingdom?
Make the answer very short. 0.03. What is the ratio of the Emissions(kt) in 1962 in Turkey to that in United Kingdom?
Offer a very short reply. 0.04. What is the ratio of the Emissions(kt) of 1963 in Turkey to that in United Kingdom?
Provide a succinct answer. 0.04. What is the ratio of the Emissions(kt) in 1960 in Uganda to that in United Arab Emirates?
Give a very brief answer. 38.33. What is the ratio of the Emissions(kt) of 1961 in Uganda to that in United Arab Emirates?
Make the answer very short. 37. What is the ratio of the Emissions(kt) of 1962 in Uganda to that in United Arab Emirates?
Ensure brevity in your answer.  23.4. What is the ratio of the Emissions(kt) of 1963 in Uganda to that in United Arab Emirates?
Make the answer very short. 19.67. What is the ratio of the Emissions(kt) in 1960 in Uganda to that in United Kingdom?
Ensure brevity in your answer.  0. What is the ratio of the Emissions(kt) in 1961 in Uganda to that in United Kingdom?
Your answer should be compact. 0. What is the ratio of the Emissions(kt) of 1962 in Uganda to that in United Kingdom?
Provide a succinct answer. 0. What is the ratio of the Emissions(kt) of 1963 in Uganda to that in United Kingdom?
Offer a very short reply. 0. What is the ratio of the Emissions(kt) in 1960 in United Arab Emirates to that in United Kingdom?
Ensure brevity in your answer.  0. What is the ratio of the Emissions(kt) of 1962 in United Arab Emirates to that in United Kingdom?
Provide a short and direct response. 0. What is the ratio of the Emissions(kt) of 1963 in United Arab Emirates to that in United Kingdom?
Provide a succinct answer. 0. What is the difference between the highest and the second highest Emissions(kt) of 1960?
Offer a terse response. 5.67e+05. What is the difference between the highest and the second highest Emissions(kt) in 1961?
Keep it short and to the point. 5.72e+05. What is the difference between the highest and the second highest Emissions(kt) of 1962?
Ensure brevity in your answer.  5.72e+05. What is the difference between the highest and the second highest Emissions(kt) in 1963?
Keep it short and to the point. 5.81e+05. What is the difference between the highest and the lowest Emissions(kt) of 1960?
Offer a very short reply. 5.84e+05. What is the difference between the highest and the lowest Emissions(kt) in 1961?
Give a very brief answer. 5.89e+05. What is the difference between the highest and the lowest Emissions(kt) of 1962?
Offer a very short reply. 5.93e+05. What is the difference between the highest and the lowest Emissions(kt) in 1963?
Provide a short and direct response. 6.04e+05. 